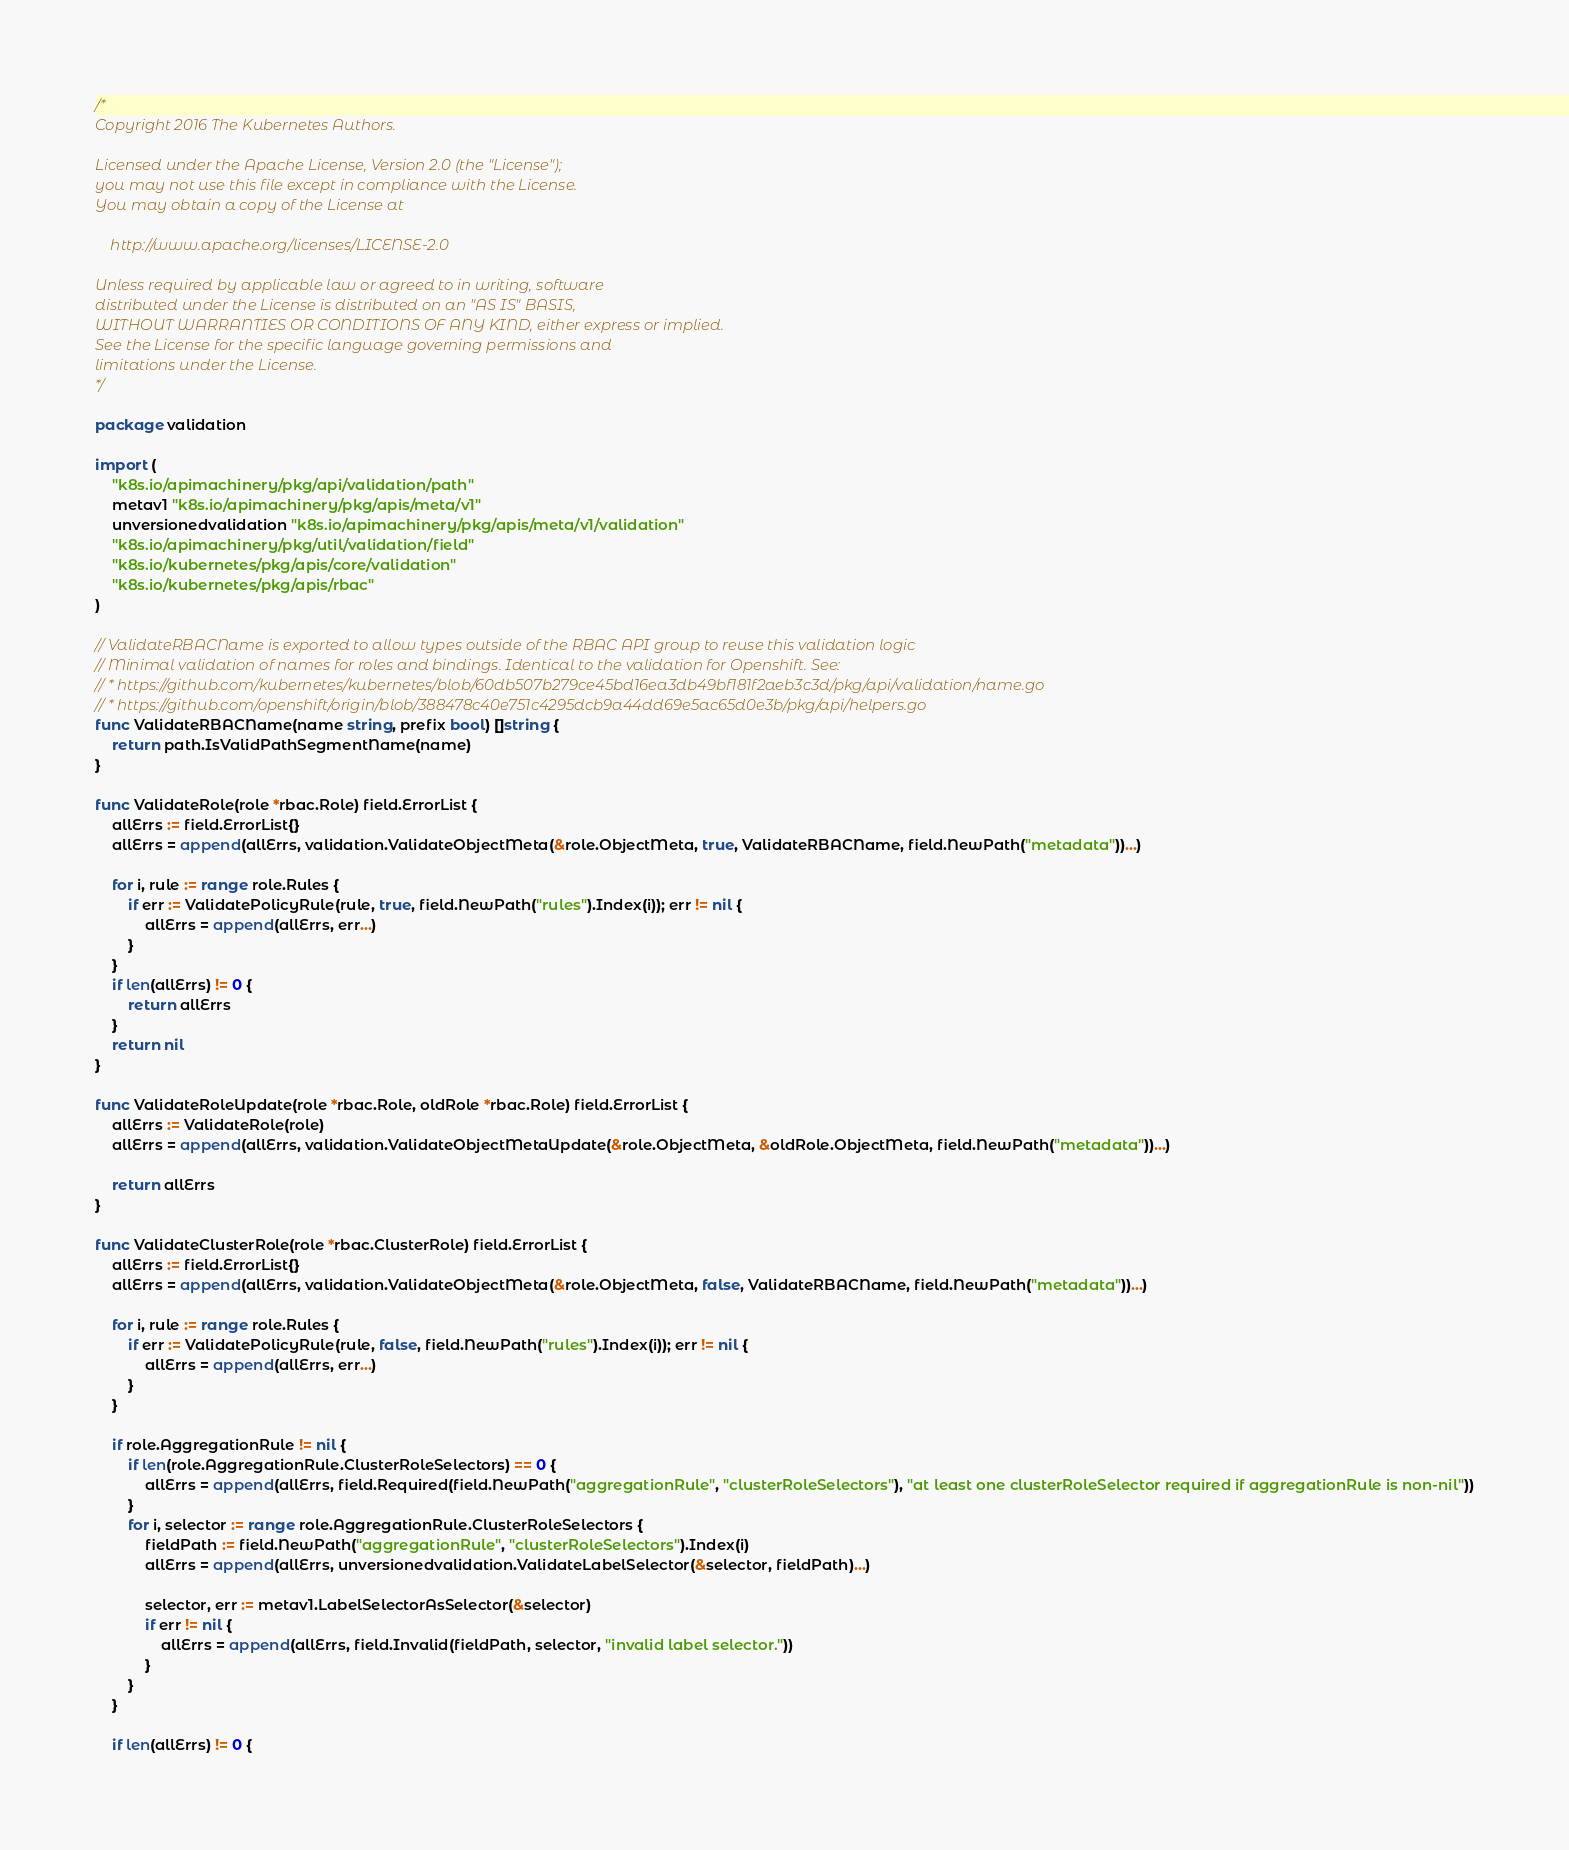Convert code to text. <code><loc_0><loc_0><loc_500><loc_500><_Go_>/*
Copyright 2016 The Kubernetes Authors.

Licensed under the Apache License, Version 2.0 (the "License");
you may not use this file except in compliance with the License.
You may obtain a copy of the License at

    http://www.apache.org/licenses/LICENSE-2.0

Unless required by applicable law or agreed to in writing, software
distributed under the License is distributed on an "AS IS" BASIS,
WITHOUT WARRANTIES OR CONDITIONS OF ANY KIND, either express or implied.
See the License for the specific language governing permissions and
limitations under the License.
*/

package validation

import (
	"k8s.io/apimachinery/pkg/api/validation/path"
	metav1 "k8s.io/apimachinery/pkg/apis/meta/v1"
	unversionedvalidation "k8s.io/apimachinery/pkg/apis/meta/v1/validation"
	"k8s.io/apimachinery/pkg/util/validation/field"
	"k8s.io/kubernetes/pkg/apis/core/validation"
	"k8s.io/kubernetes/pkg/apis/rbac"
)

// ValidateRBACName is exported to allow types outside of the RBAC API group to reuse this validation logic
// Minimal validation of names for roles and bindings. Identical to the validation for Openshift. See:
// * https://github.com/kubernetes/kubernetes/blob/60db507b279ce45bd16ea3db49bf181f2aeb3c3d/pkg/api/validation/name.go
// * https://github.com/openshift/origin/blob/388478c40e751c4295dcb9a44dd69e5ac65d0e3b/pkg/api/helpers.go
func ValidateRBACName(name string, prefix bool) []string {
	return path.IsValidPathSegmentName(name)
}

func ValidateRole(role *rbac.Role) field.ErrorList {
	allErrs := field.ErrorList{}
	allErrs = append(allErrs, validation.ValidateObjectMeta(&role.ObjectMeta, true, ValidateRBACName, field.NewPath("metadata"))...)

	for i, rule := range role.Rules {
		if err := ValidatePolicyRule(rule, true, field.NewPath("rules").Index(i)); err != nil {
			allErrs = append(allErrs, err...)
		}
	}
	if len(allErrs) != 0 {
		return allErrs
	}
	return nil
}

func ValidateRoleUpdate(role *rbac.Role, oldRole *rbac.Role) field.ErrorList {
	allErrs := ValidateRole(role)
	allErrs = append(allErrs, validation.ValidateObjectMetaUpdate(&role.ObjectMeta, &oldRole.ObjectMeta, field.NewPath("metadata"))...)

	return allErrs
}

func ValidateClusterRole(role *rbac.ClusterRole) field.ErrorList {
	allErrs := field.ErrorList{}
	allErrs = append(allErrs, validation.ValidateObjectMeta(&role.ObjectMeta, false, ValidateRBACName, field.NewPath("metadata"))...)

	for i, rule := range role.Rules {
		if err := ValidatePolicyRule(rule, false, field.NewPath("rules").Index(i)); err != nil {
			allErrs = append(allErrs, err...)
		}
	}

	if role.AggregationRule != nil {
		if len(role.AggregationRule.ClusterRoleSelectors) == 0 {
			allErrs = append(allErrs, field.Required(field.NewPath("aggregationRule", "clusterRoleSelectors"), "at least one clusterRoleSelector required if aggregationRule is non-nil"))
		}
		for i, selector := range role.AggregationRule.ClusterRoleSelectors {
			fieldPath := field.NewPath("aggregationRule", "clusterRoleSelectors").Index(i)
			allErrs = append(allErrs, unversionedvalidation.ValidateLabelSelector(&selector, fieldPath)...)

			selector, err := metav1.LabelSelectorAsSelector(&selector)
			if err != nil {
				allErrs = append(allErrs, field.Invalid(fieldPath, selector, "invalid label selector."))
			}
		}
	}

	if len(allErrs) != 0 {</code> 